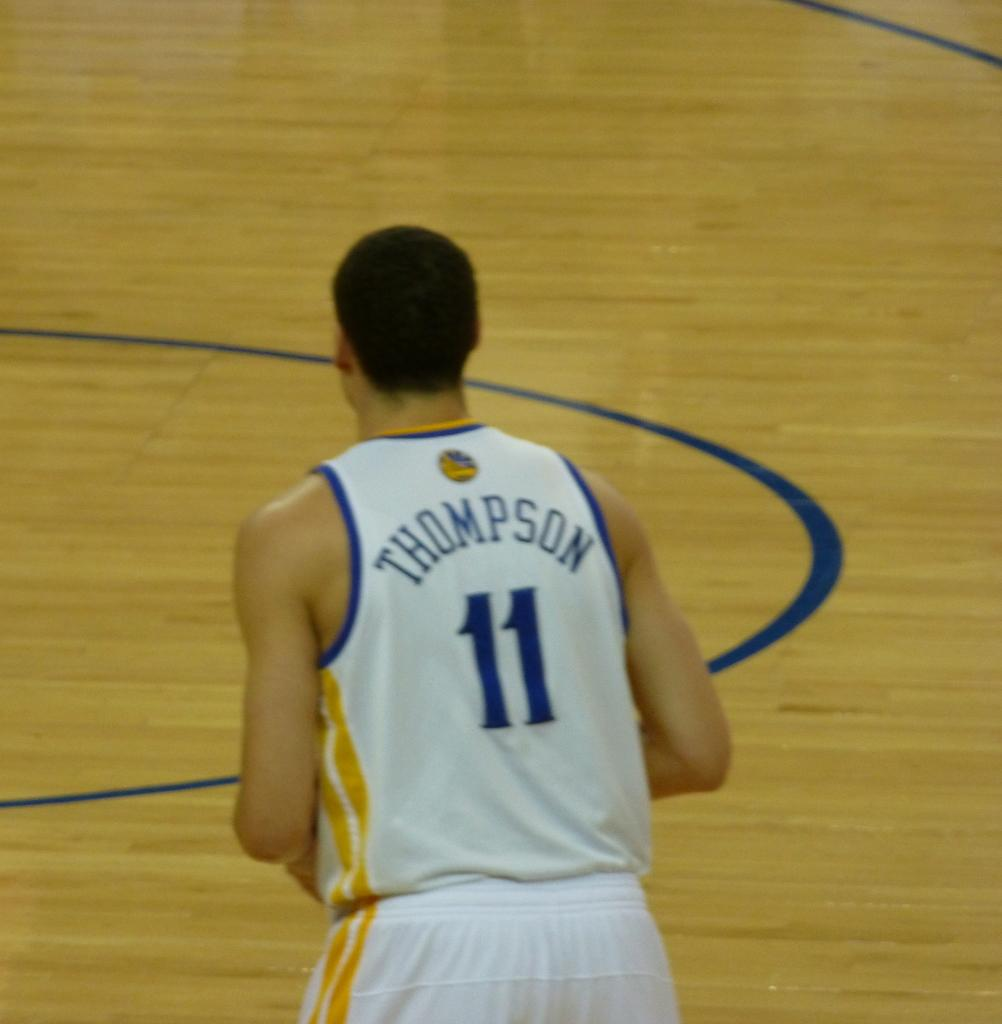<image>
Relay a brief, clear account of the picture shown. a player with the name Thompson on their jersey 